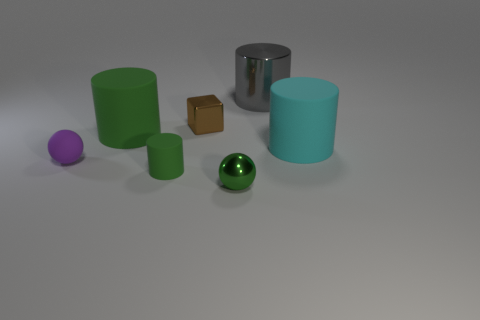Add 2 large brown blocks. How many objects exist? 9 Subtract all cylinders. How many objects are left? 3 Subtract 0 yellow balls. How many objects are left? 7 Subtract all blue shiny balls. Subtract all spheres. How many objects are left? 5 Add 7 big cyan objects. How many big cyan objects are left? 8 Add 7 tiny brown shiny objects. How many tiny brown shiny objects exist? 8 